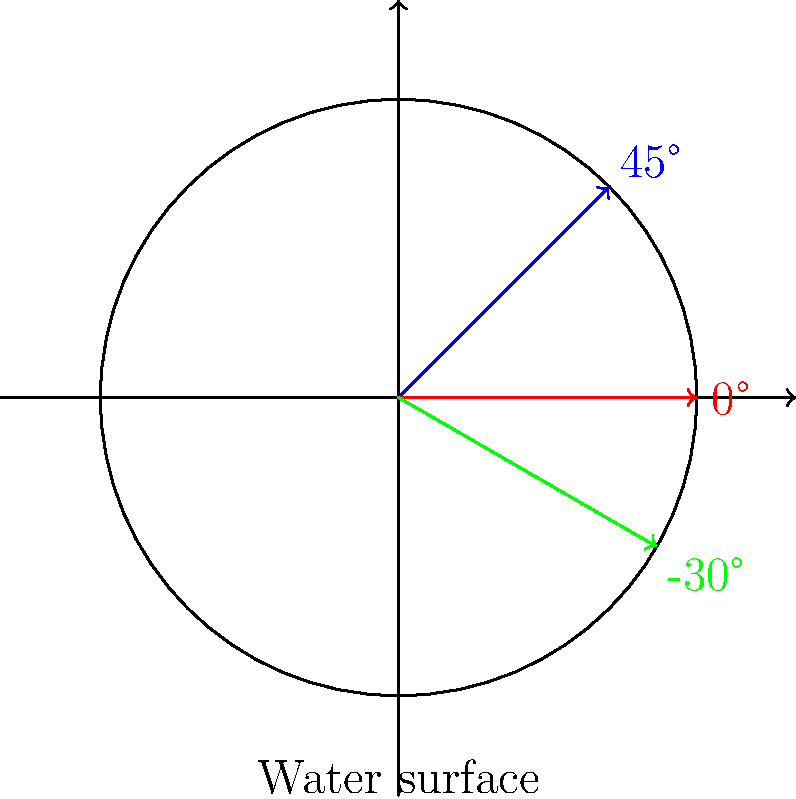In freestyle swimming, which arm entry angle is generally considered most efficient for reducing drag and maintaining forward momentum? To understand the most efficient arm entry angle in freestyle swimming, let's consider the biomechanics involved:

1. The arm entry angle affects water resistance and propulsion efficiency.

2. A 45° angle (blue line in the diagram):
   - Creates more splash and turbulence
   - Increases drag
   - Requires more energy to push water backwards

3. A 0° angle (red line in the diagram):
   - Causes the arm to slap the water surface
   - Creates excessive splash
   - Disrupts smooth body rotation

4. A slightly negative angle, around -30° (green line in the diagram):
   - Allows for a clean entry with minimal splash
   - Reduces drag
   - Facilitates a smooth catch phase
   - Enables better body rotation and streamlining

5. The -30° angle positions the hand to enter the water fingertips first, followed by the wrist and forearm.

6. This angle helps maintain forward momentum by reducing the braking effect of arm entry.

7. It also sets up the arm for an efficient catch and pull phase, maximizing propulsion.

Therefore, the most efficient arm entry angle for freestyle swimming is generally considered to be around -30°, as it provides the best balance between drag reduction and propulsion setup.
Answer: Approximately -30° 